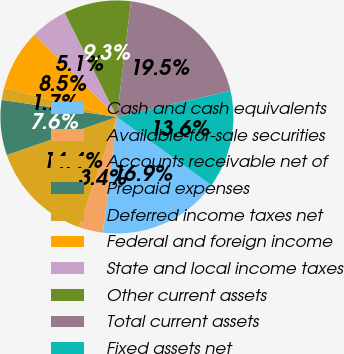Convert chart to OTSL. <chart><loc_0><loc_0><loc_500><loc_500><pie_chart><fcel>Cash and cash equivalents<fcel>Available-for-sale securities<fcel>Accounts receivable net of<fcel>Prepaid expenses<fcel>Deferred income taxes net<fcel>Federal and foreign income<fcel>State and local income taxes<fcel>Other current assets<fcel>Total current assets<fcel>Fixed assets net<nl><fcel>16.95%<fcel>3.39%<fcel>14.41%<fcel>7.63%<fcel>1.7%<fcel>8.47%<fcel>5.09%<fcel>9.32%<fcel>19.49%<fcel>13.56%<nl></chart> 